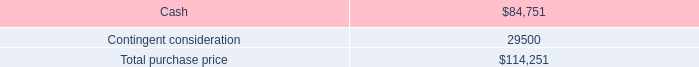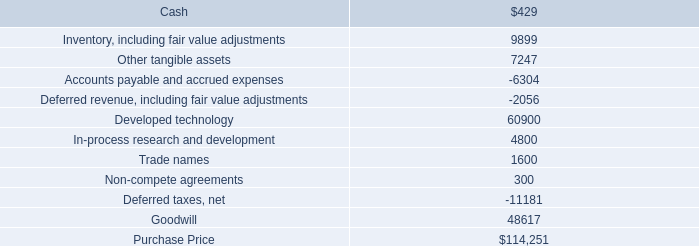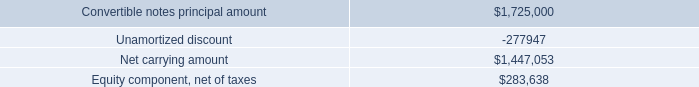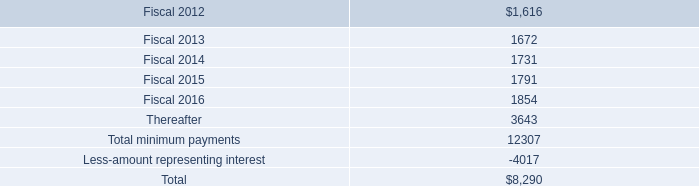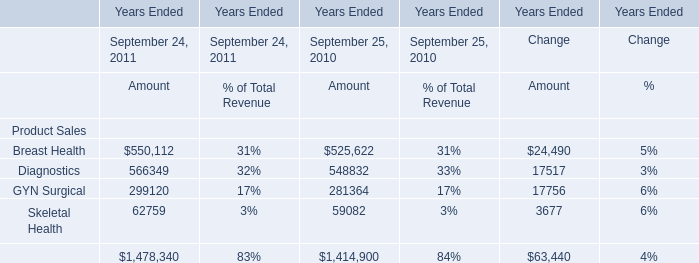What was the total amount of Revenue for Product Sales greater than 500000 for the year ended September 25, 2010? 
Computations: (525622 + 548832)
Answer: 1074454.0. 